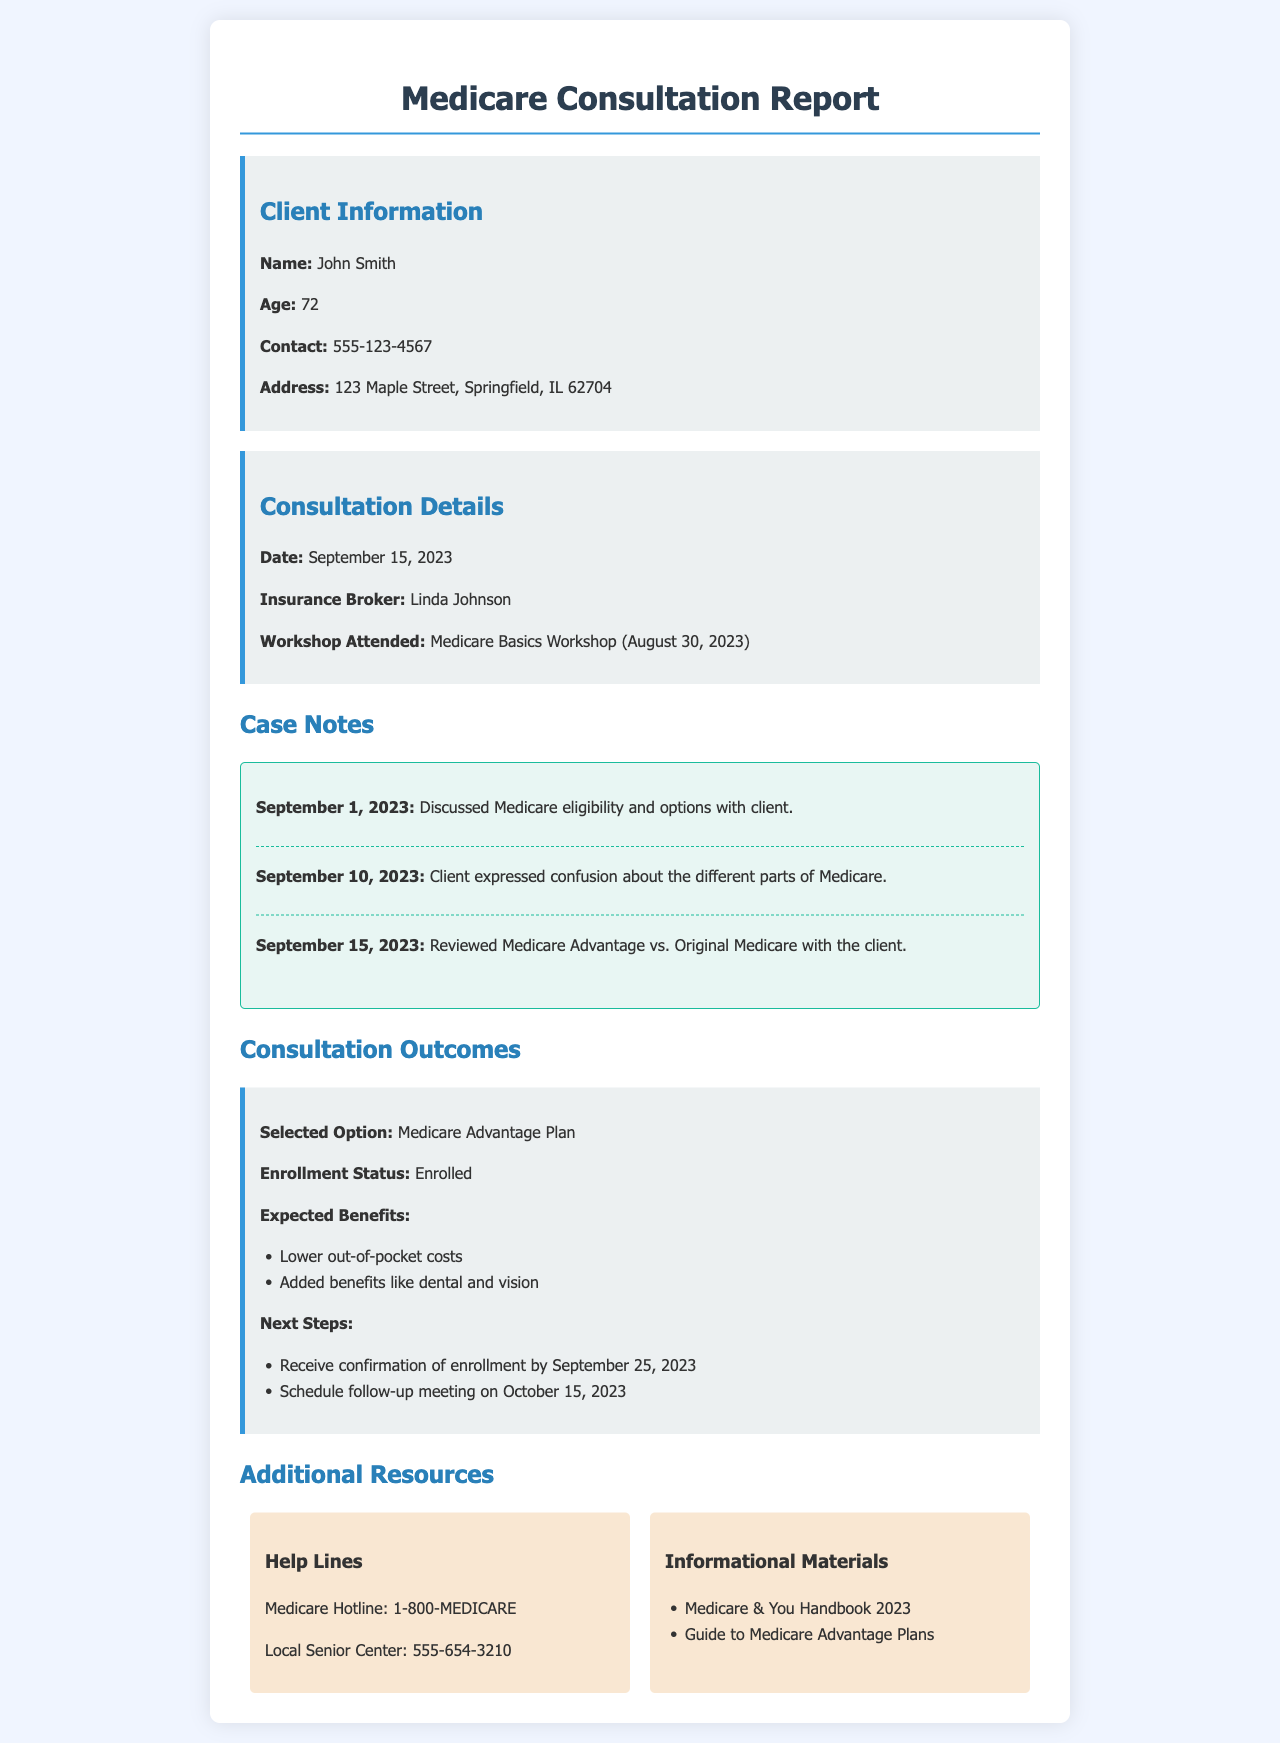What is the client's name? The client's name is mentioned at the beginning of the document under Client Information.
Answer: John Smith What is the age of the client? The client's age is listed in the Client Information section of the document.
Answer: 72 Who is the insurance broker? The name of the insurance broker is provided in the Consultation Details section.
Answer: Linda Johnson What date did the consultation take place? The consultation date is specified in the Consultation Details area of the document.
Answer: September 15, 2023 What workshop did the client attend? The attended workshop is indicated in the Consultation Details portion of the document.
Answer: Medicare Basics Workshop What option did the client select? The selected option is noted in the Consultation Outcomes section.
Answer: Medicare Advantage Plan When is the expected confirmation of enrollment? The expected confirmation date is outlined in the Next Steps of the Consultation Outcomes section.
Answer: September 25, 2023 What benefit is NOT expected from the selected option? The benefits listed under expected benefits provide insights into what is included or excluded.
Answer: None (all listed benefits are expected) What is the contact number for Medicare? The document provides a hotline number in the Additional Resources section.
Answer: 1-800-MEDICARE What was the client confused about? The client's confusion is documented in the case notes prior to the consultation.
Answer: Different parts of Medicare 